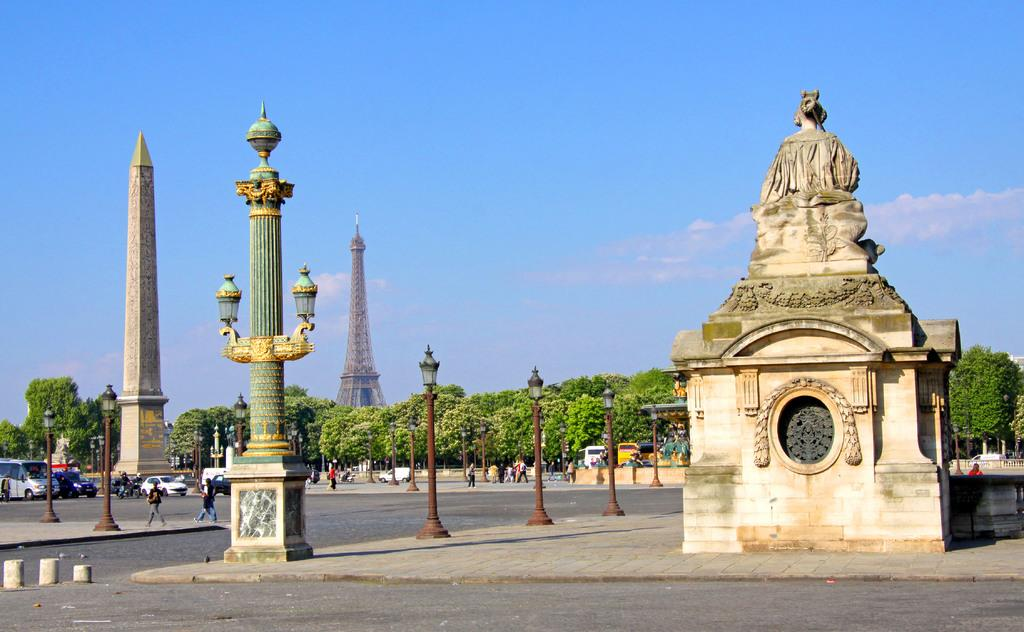What is the main subject in the image? There is a sculpture in the image. What other structures can be seen in the image? There is a tower and an obelisk in the image. What type of vegetation is present in the image? There are trees in the image. What type of illumination is present in the image? There are lights in the image. What type of transportation is present in the image? There are vehicles in the image. Are there any people present in the image? Yes, there are people in the image. What can be seen in the background of the image? The sky is visible in the background of the image. What type of songs can be heard playing from the unit in the image? There is no unit or songs present in the image. 